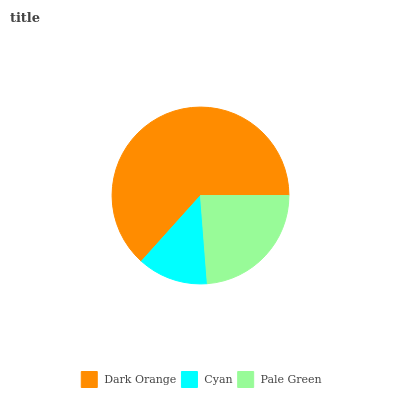Is Cyan the minimum?
Answer yes or no. Yes. Is Dark Orange the maximum?
Answer yes or no. Yes. Is Pale Green the minimum?
Answer yes or no. No. Is Pale Green the maximum?
Answer yes or no. No. Is Pale Green greater than Cyan?
Answer yes or no. Yes. Is Cyan less than Pale Green?
Answer yes or no. Yes. Is Cyan greater than Pale Green?
Answer yes or no. No. Is Pale Green less than Cyan?
Answer yes or no. No. Is Pale Green the high median?
Answer yes or no. Yes. Is Pale Green the low median?
Answer yes or no. Yes. Is Cyan the high median?
Answer yes or no. No. Is Dark Orange the low median?
Answer yes or no. No. 